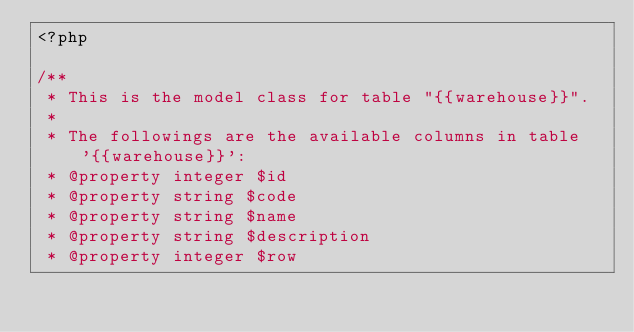<code> <loc_0><loc_0><loc_500><loc_500><_PHP_><?php

/**
 * This is the model class for table "{{warehouse}}".
 *
 * The followings are the available columns in table '{{warehouse}}':
 * @property integer $id
 * @property string $code
 * @property string $name
 * @property string $description
 * @property integer $row</code> 